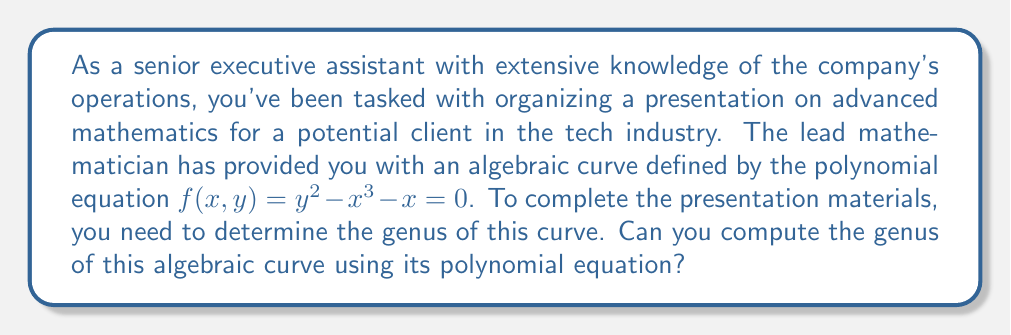Solve this math problem. To compute the genus of the given algebraic curve, we'll follow these steps:

1) First, we need to identify the type of curve. The equation $y^2 = x^3 + x$ is in the form of an elliptic curve.

2) For an elliptic curve given by the general Weierstrass equation $y^2 = x^3 + ax + b$, we can determine if it's smooth by checking if its discriminant is non-zero.

3) The discriminant $\Delta$ is given by:

   $$\Delta = -16(4a^3 + 27b^2)$$

4) In our case, $a = 1$ and $b = 0$. Let's calculate the discriminant:

   $$\Delta = -16(4(1)^3 + 27(0)^2) = -16(4) = -64$$

5) Since $\Delta \neq 0$, the curve is smooth.

6) For a smooth elliptic curve, the genus is always 1.

Therefore, the genus of the curve $y^2 = x^3 + x$ is 1.
Answer: 1 